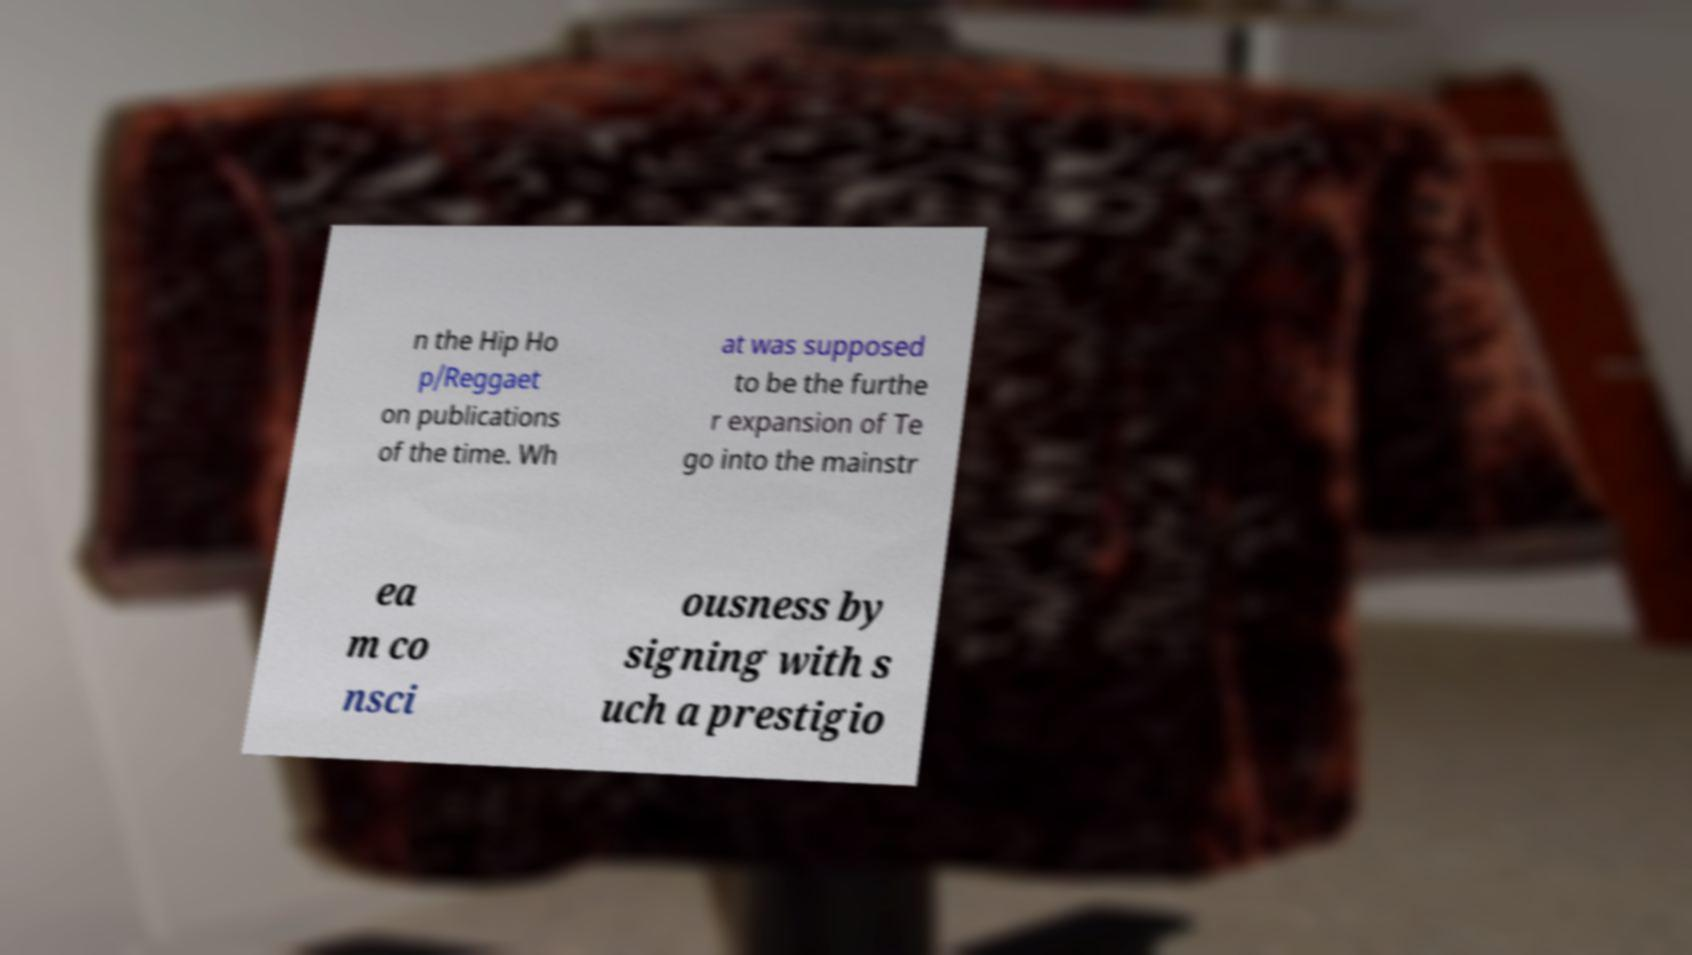What messages or text are displayed in this image? I need them in a readable, typed format. n the Hip Ho p/Reggaet on publications of the time. Wh at was supposed to be the furthe r expansion of Te go into the mainstr ea m co nsci ousness by signing with s uch a prestigio 